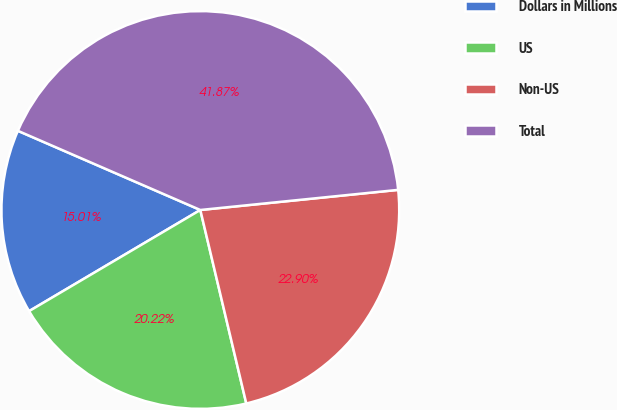Convert chart to OTSL. <chart><loc_0><loc_0><loc_500><loc_500><pie_chart><fcel>Dollars in Millions<fcel>US<fcel>Non-US<fcel>Total<nl><fcel>15.01%<fcel>20.22%<fcel>22.9%<fcel>41.87%<nl></chart> 